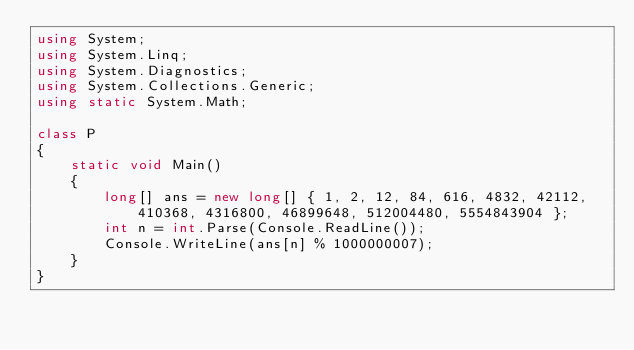Convert code to text. <code><loc_0><loc_0><loc_500><loc_500><_C#_>using System;
using System.Linq;
using System.Diagnostics;
using System.Collections.Generic;
using static System.Math;
 
class P
{
    static void Main()
    {
        long[] ans = new long[] { 1, 2, 12, 84, 616, 4832, 42112, 410368, 4316800, 46899648, 512004480, 5554843904 };
        int n = int.Parse(Console.ReadLine());
        Console.WriteLine(ans[n] % 1000000007);
    }
}</code> 